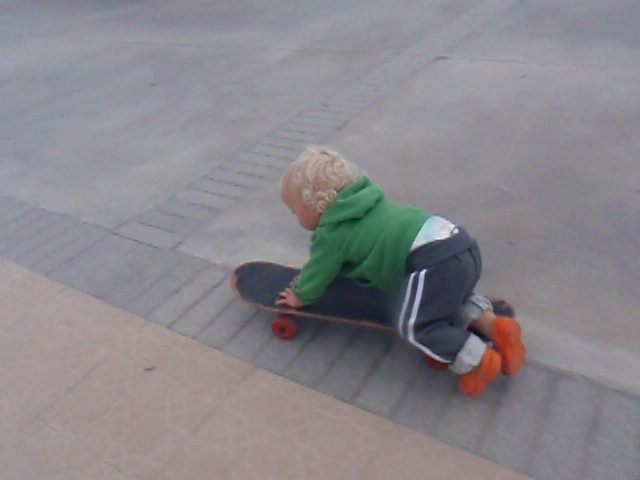<image>What is this trick called? I am not sure what this trick is called. Some possibilities include "beginner's", "skateboarding", or "kneeling". What happened to the motorcycle? There is no motorcycle in the image. It's not clear what happened to the motorcycle. What is his number? The number is not visible in the image. What is his number? I don't know his number. There is no number visible in the image. What happened to the motorcycle? I am not sure what happened to the motorcycle. It can be either gone or broken. What is this trick called? I don't know what this trick is called. It could be called "beginner's", "skateboarding", "skating", or something else. 